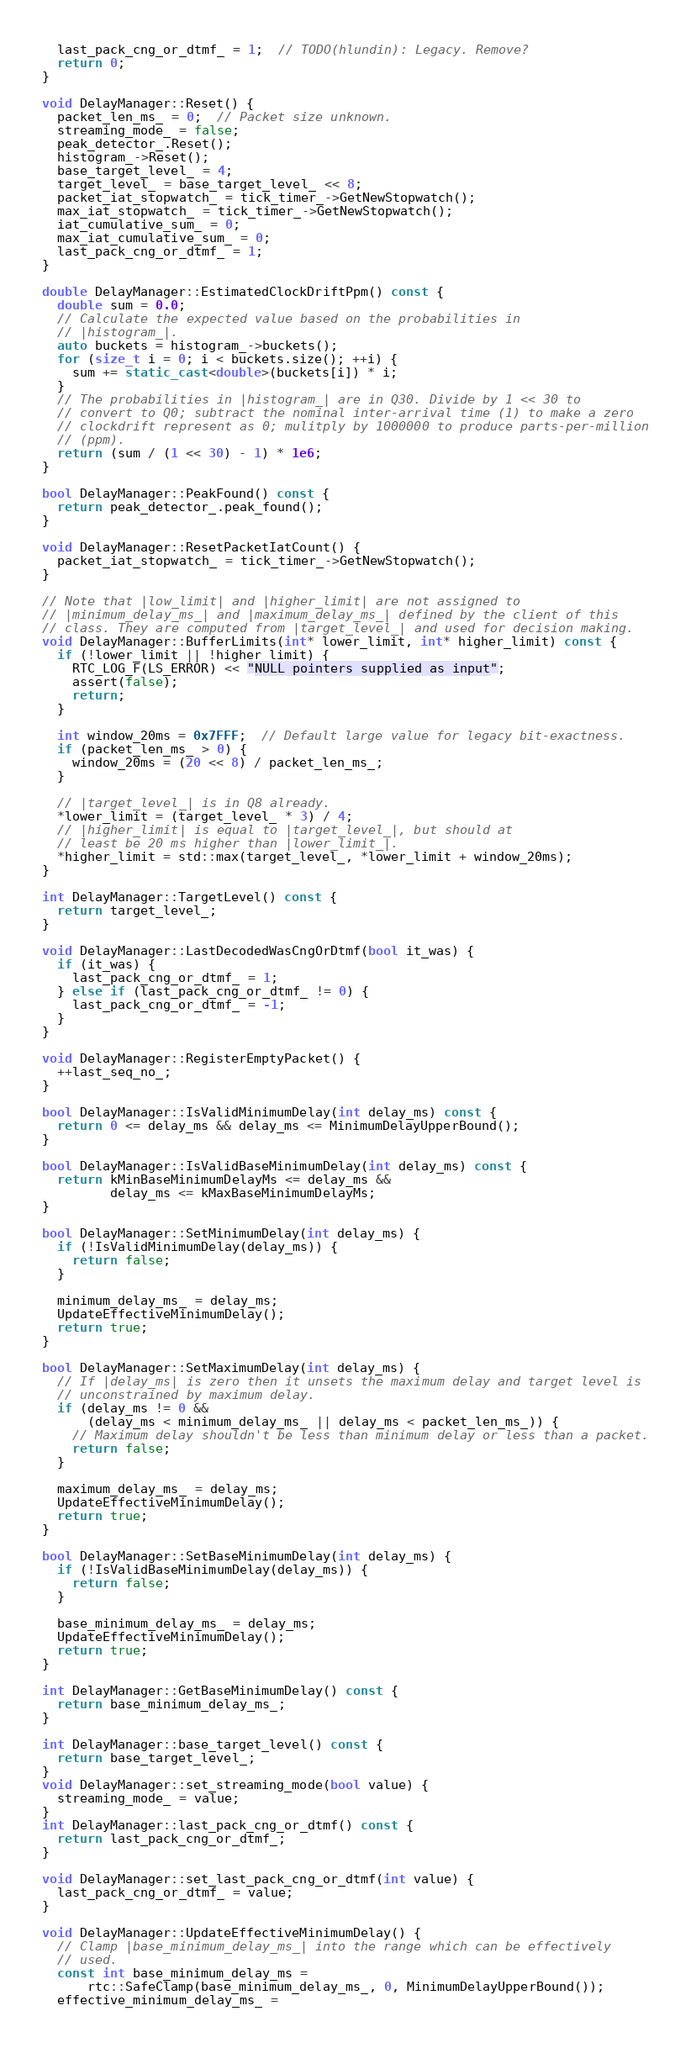Convert code to text. <code><loc_0><loc_0><loc_500><loc_500><_C++_>  last_pack_cng_or_dtmf_ = 1;  // TODO(hlundin): Legacy. Remove?
  return 0;
}

void DelayManager::Reset() {
  packet_len_ms_ = 0;  // Packet size unknown.
  streaming_mode_ = false;
  peak_detector_.Reset();
  histogram_->Reset();
  base_target_level_ = 4;
  target_level_ = base_target_level_ << 8;
  packet_iat_stopwatch_ = tick_timer_->GetNewStopwatch();
  max_iat_stopwatch_ = tick_timer_->GetNewStopwatch();
  iat_cumulative_sum_ = 0;
  max_iat_cumulative_sum_ = 0;
  last_pack_cng_or_dtmf_ = 1;
}

double DelayManager::EstimatedClockDriftPpm() const {
  double sum = 0.0;
  // Calculate the expected value based on the probabilities in
  // |histogram_|.
  auto buckets = histogram_->buckets();
  for (size_t i = 0; i < buckets.size(); ++i) {
    sum += static_cast<double>(buckets[i]) * i;
  }
  // The probabilities in |histogram_| are in Q30. Divide by 1 << 30 to
  // convert to Q0; subtract the nominal inter-arrival time (1) to make a zero
  // clockdrift represent as 0; mulitply by 1000000 to produce parts-per-million
  // (ppm).
  return (sum / (1 << 30) - 1) * 1e6;
}

bool DelayManager::PeakFound() const {
  return peak_detector_.peak_found();
}

void DelayManager::ResetPacketIatCount() {
  packet_iat_stopwatch_ = tick_timer_->GetNewStopwatch();
}

// Note that |low_limit| and |higher_limit| are not assigned to
// |minimum_delay_ms_| and |maximum_delay_ms_| defined by the client of this
// class. They are computed from |target_level_| and used for decision making.
void DelayManager::BufferLimits(int* lower_limit, int* higher_limit) const {
  if (!lower_limit || !higher_limit) {
    RTC_LOG_F(LS_ERROR) << "NULL pointers supplied as input";
    assert(false);
    return;
  }

  int window_20ms = 0x7FFF;  // Default large value for legacy bit-exactness.
  if (packet_len_ms_ > 0) {
    window_20ms = (20 << 8) / packet_len_ms_;
  }

  // |target_level_| is in Q8 already.
  *lower_limit = (target_level_ * 3) / 4;
  // |higher_limit| is equal to |target_level_|, but should at
  // least be 20 ms higher than |lower_limit_|.
  *higher_limit = std::max(target_level_, *lower_limit + window_20ms);
}

int DelayManager::TargetLevel() const {
  return target_level_;
}

void DelayManager::LastDecodedWasCngOrDtmf(bool it_was) {
  if (it_was) {
    last_pack_cng_or_dtmf_ = 1;
  } else if (last_pack_cng_or_dtmf_ != 0) {
    last_pack_cng_or_dtmf_ = -1;
  }
}

void DelayManager::RegisterEmptyPacket() {
  ++last_seq_no_;
}

bool DelayManager::IsValidMinimumDelay(int delay_ms) const {
  return 0 <= delay_ms && delay_ms <= MinimumDelayUpperBound();
}

bool DelayManager::IsValidBaseMinimumDelay(int delay_ms) const {
  return kMinBaseMinimumDelayMs <= delay_ms &&
         delay_ms <= kMaxBaseMinimumDelayMs;
}

bool DelayManager::SetMinimumDelay(int delay_ms) {
  if (!IsValidMinimumDelay(delay_ms)) {
    return false;
  }

  minimum_delay_ms_ = delay_ms;
  UpdateEffectiveMinimumDelay();
  return true;
}

bool DelayManager::SetMaximumDelay(int delay_ms) {
  // If |delay_ms| is zero then it unsets the maximum delay and target level is
  // unconstrained by maximum delay.
  if (delay_ms != 0 &&
      (delay_ms < minimum_delay_ms_ || delay_ms < packet_len_ms_)) {
    // Maximum delay shouldn't be less than minimum delay or less than a packet.
    return false;
  }

  maximum_delay_ms_ = delay_ms;
  UpdateEffectiveMinimumDelay();
  return true;
}

bool DelayManager::SetBaseMinimumDelay(int delay_ms) {
  if (!IsValidBaseMinimumDelay(delay_ms)) {
    return false;
  }

  base_minimum_delay_ms_ = delay_ms;
  UpdateEffectiveMinimumDelay();
  return true;
}

int DelayManager::GetBaseMinimumDelay() const {
  return base_minimum_delay_ms_;
}

int DelayManager::base_target_level() const {
  return base_target_level_;
}
void DelayManager::set_streaming_mode(bool value) {
  streaming_mode_ = value;
}
int DelayManager::last_pack_cng_or_dtmf() const {
  return last_pack_cng_or_dtmf_;
}

void DelayManager::set_last_pack_cng_or_dtmf(int value) {
  last_pack_cng_or_dtmf_ = value;
}

void DelayManager::UpdateEffectiveMinimumDelay() {
  // Clamp |base_minimum_delay_ms_| into the range which can be effectively
  // used.
  const int base_minimum_delay_ms =
      rtc::SafeClamp(base_minimum_delay_ms_, 0, MinimumDelayUpperBound());
  effective_minimum_delay_ms_ =</code> 